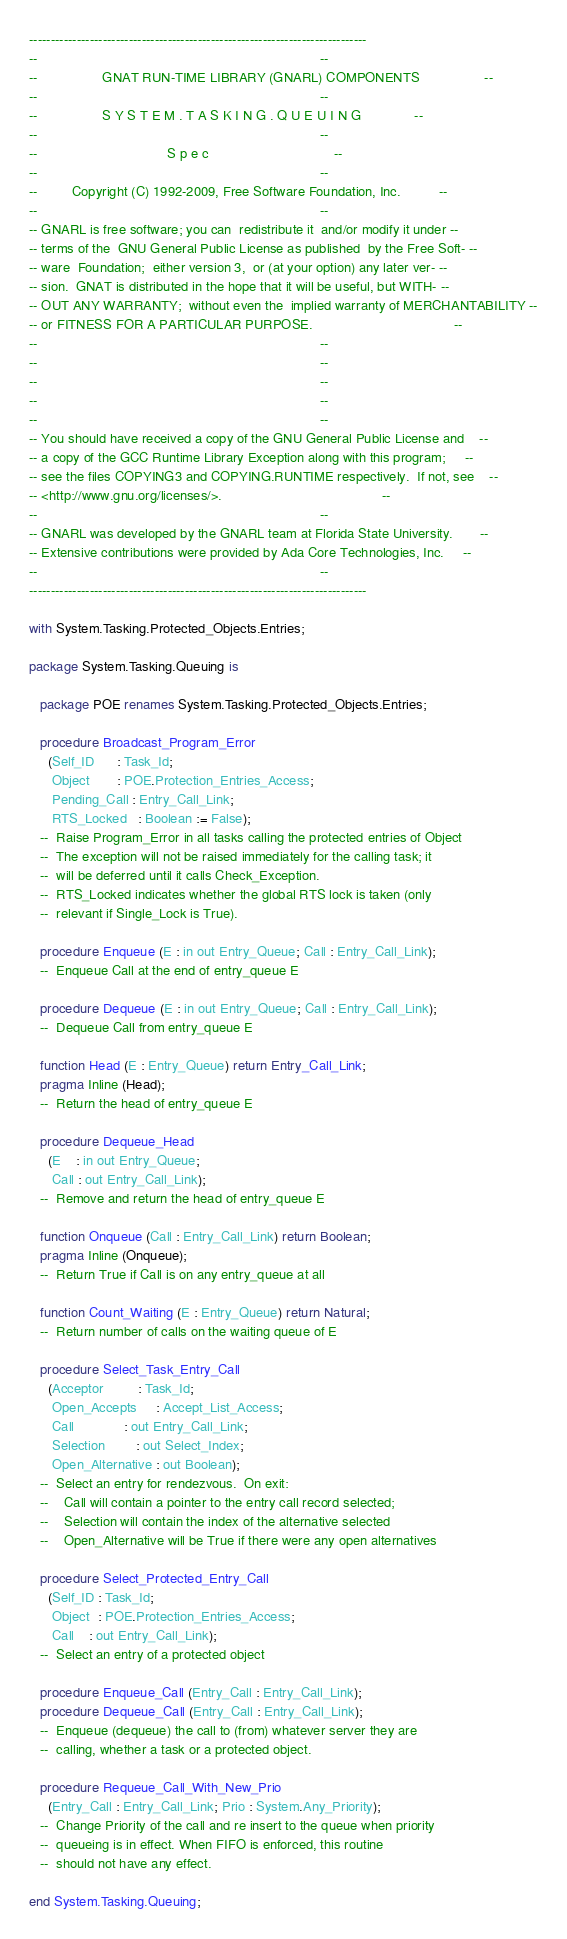Convert code to text. <code><loc_0><loc_0><loc_500><loc_500><_Ada_>------------------------------------------------------------------------------
--                                                                          --
--                 GNAT RUN-TIME LIBRARY (GNARL) COMPONENTS                 --
--                                                                          --
--                 S Y S T E M . T A S K I N G . Q U E U I N G              --
--                                                                          --
--                                  S p e c                                 --
--                                                                          --
--         Copyright (C) 1992-2009, Free Software Foundation, Inc.          --
--                                                                          --
-- GNARL is free software; you can  redistribute it  and/or modify it under --
-- terms of the  GNU General Public License as published  by the Free Soft- --
-- ware  Foundation;  either version 3,  or (at your option) any later ver- --
-- sion.  GNAT is distributed in the hope that it will be useful, but WITH- --
-- OUT ANY WARRANTY;  without even the  implied warranty of MERCHANTABILITY --
-- or FITNESS FOR A PARTICULAR PURPOSE.                                     --
--                                                                          --
--                                                                          --
--                                                                          --
--                                                                          --
--                                                                          --
-- You should have received a copy of the GNU General Public License and    --
-- a copy of the GCC Runtime Library Exception along with this program;     --
-- see the files COPYING3 and COPYING.RUNTIME respectively.  If not, see    --
-- <http://www.gnu.org/licenses/>.                                          --
--                                                                          --
-- GNARL was developed by the GNARL team at Florida State University.       --
-- Extensive contributions were provided by Ada Core Technologies, Inc.     --
--                                                                          --
------------------------------------------------------------------------------

with System.Tasking.Protected_Objects.Entries;

package System.Tasking.Queuing is

   package POE renames System.Tasking.Protected_Objects.Entries;

   procedure Broadcast_Program_Error
     (Self_ID      : Task_Id;
      Object       : POE.Protection_Entries_Access;
      Pending_Call : Entry_Call_Link;
      RTS_Locked   : Boolean := False);
   --  Raise Program_Error in all tasks calling the protected entries of Object
   --  The exception will not be raised immediately for the calling task; it
   --  will be deferred until it calls Check_Exception.
   --  RTS_Locked indicates whether the global RTS lock is taken (only
   --  relevant if Single_Lock is True).

   procedure Enqueue (E : in out Entry_Queue; Call : Entry_Call_Link);
   --  Enqueue Call at the end of entry_queue E

   procedure Dequeue (E : in out Entry_Queue; Call : Entry_Call_Link);
   --  Dequeue Call from entry_queue E

   function Head (E : Entry_Queue) return Entry_Call_Link;
   pragma Inline (Head);
   --  Return the head of entry_queue E

   procedure Dequeue_Head
     (E    : in out Entry_Queue;
      Call : out Entry_Call_Link);
   --  Remove and return the head of entry_queue E

   function Onqueue (Call : Entry_Call_Link) return Boolean;
   pragma Inline (Onqueue);
   --  Return True if Call is on any entry_queue at all

   function Count_Waiting (E : Entry_Queue) return Natural;
   --  Return number of calls on the waiting queue of E

   procedure Select_Task_Entry_Call
     (Acceptor         : Task_Id;
      Open_Accepts     : Accept_List_Access;
      Call             : out Entry_Call_Link;
      Selection        : out Select_Index;
      Open_Alternative : out Boolean);
   --  Select an entry for rendezvous.  On exit:
   --    Call will contain a pointer to the entry call record selected;
   --    Selection will contain the index of the alternative selected
   --    Open_Alternative will be True if there were any open alternatives

   procedure Select_Protected_Entry_Call
     (Self_ID : Task_Id;
      Object  : POE.Protection_Entries_Access;
      Call    : out Entry_Call_Link);
   --  Select an entry of a protected object

   procedure Enqueue_Call (Entry_Call : Entry_Call_Link);
   procedure Dequeue_Call (Entry_Call : Entry_Call_Link);
   --  Enqueue (dequeue) the call to (from) whatever server they are
   --  calling, whether a task or a protected object.

   procedure Requeue_Call_With_New_Prio
     (Entry_Call : Entry_Call_Link; Prio : System.Any_Priority);
   --  Change Priority of the call and re insert to the queue when priority
   --  queueing is in effect. When FIFO is enforced, this routine
   --  should not have any effect.

end System.Tasking.Queuing;
</code> 